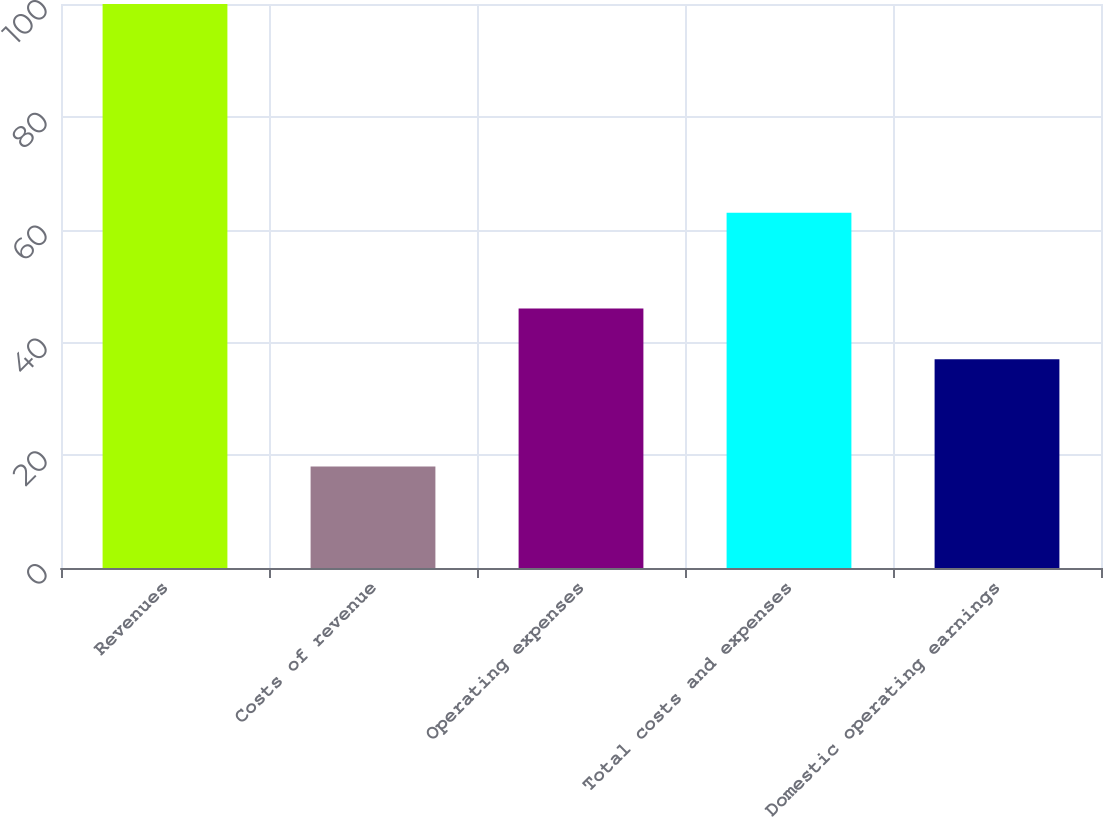<chart> <loc_0><loc_0><loc_500><loc_500><bar_chart><fcel>Revenues<fcel>Costs of revenue<fcel>Operating expenses<fcel>Total costs and expenses<fcel>Domestic operating earnings<nl><fcel>100<fcel>18<fcel>46<fcel>63<fcel>37<nl></chart> 